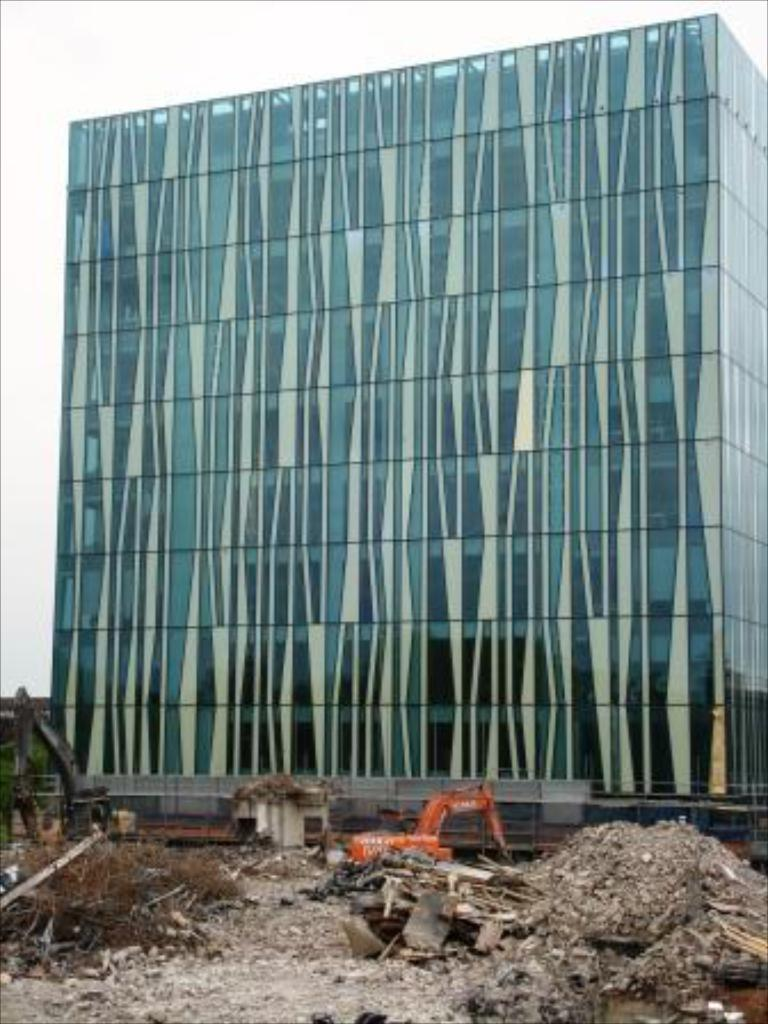What type of structure is present in the image? There is a building in the image. What else can be seen in the image besides the building? There are vehicles in the image. What part of the natural environment is visible in the image? The sky is visible in the image. What type of flowers can be seen growing near the building in the image? There are no flowers visible in the image; it only features a building and vehicles. 